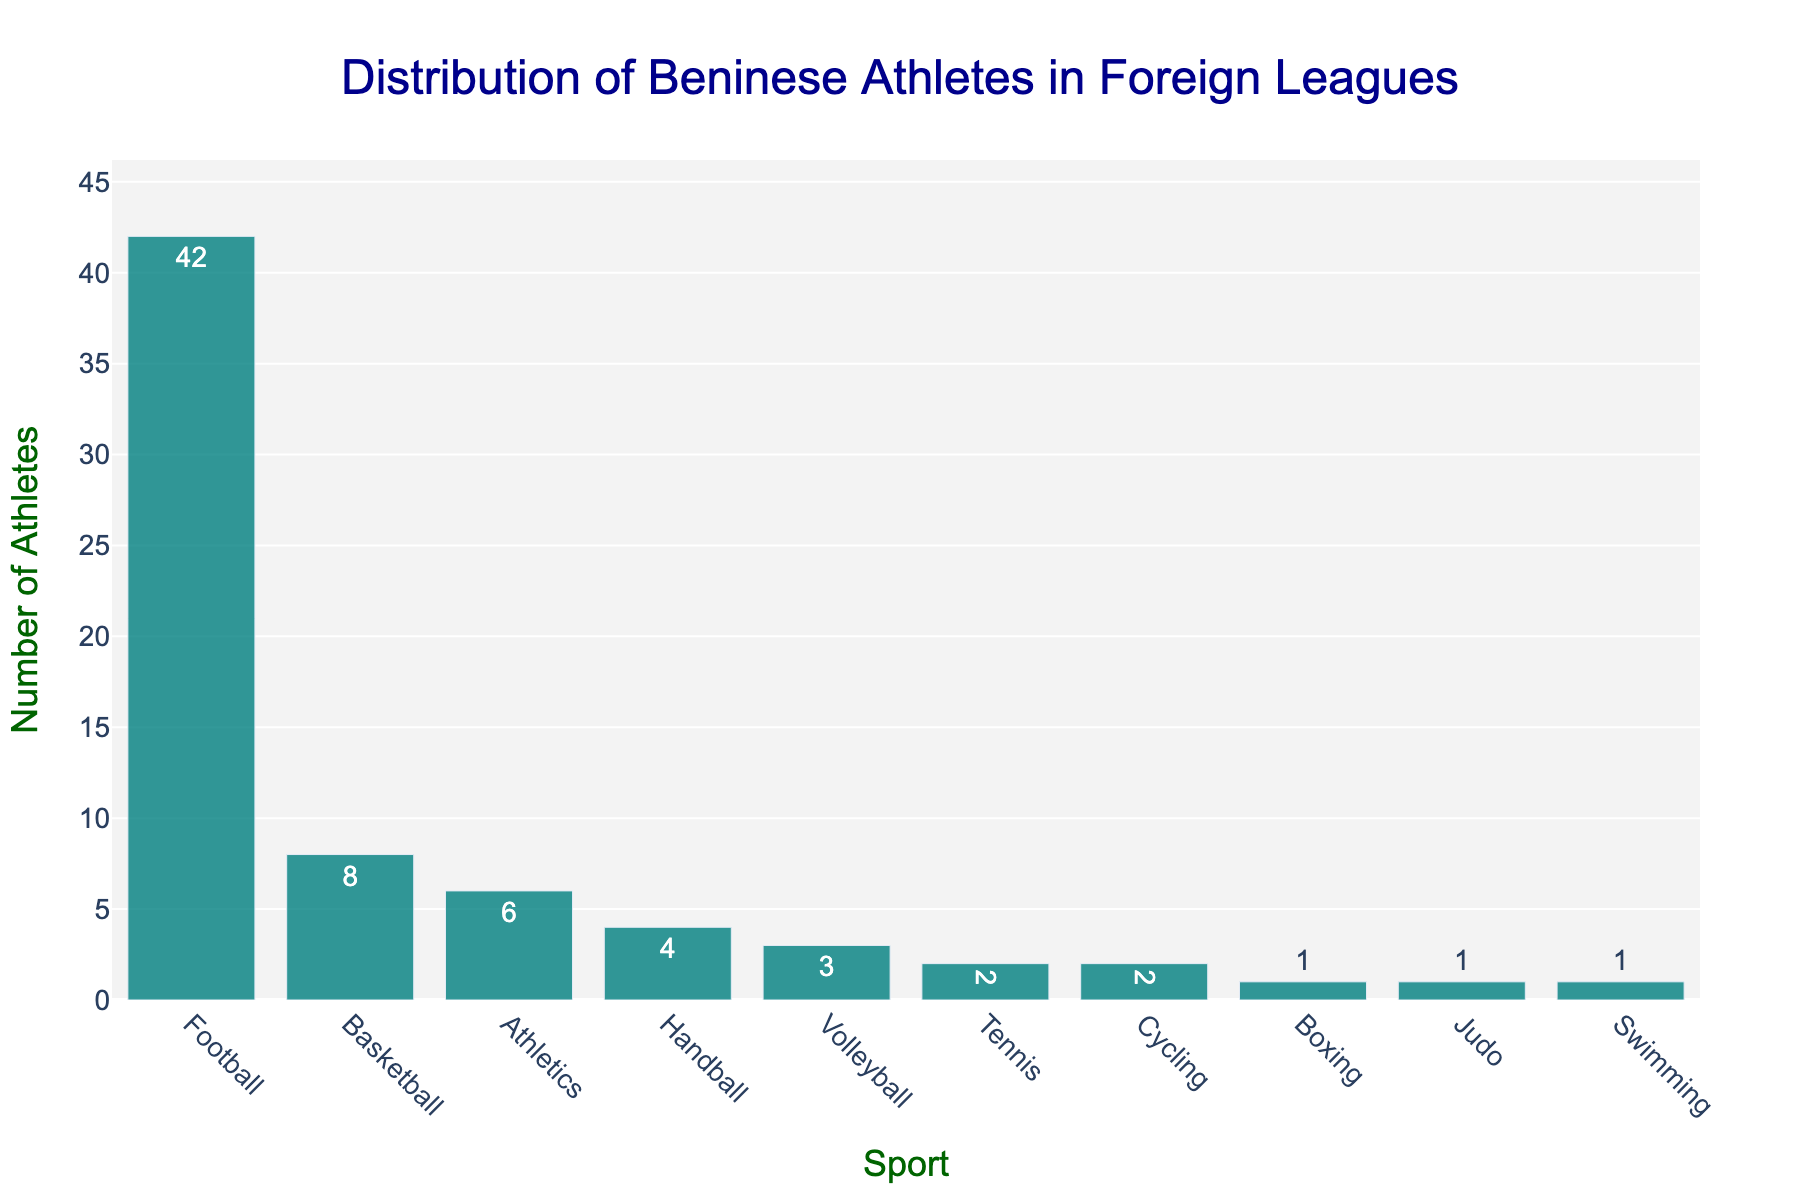What's the most popular sport for Beninese athletes in foreign leagues? The bar representing Football is the tallest in the chart, indicating it has the highest number of athletes.
Answer: Football How many more Beninese athletes play Football compared to Handball in foreign leagues? Football has 42 athletes and Handball has 4 athletes. The difference is 42 - 4.
Answer: 38 Which sport has the least number of Beninese athletes playing in foreign leagues? The bars for Boxing, Judo, and Swimming are the shortest, indicating these sports have the lowest number of athletes, which is 1 each.
Answer: Boxing, Judo, and Swimming What's the total number of Beninese athletes playing in Athletics and Volleyball combined in foreign leagues? Athletics has 6 athletes and Volleyball has 3 athletes. The total is 6 + 3.
Answer: 9 Are there more Beninese athletes playing Basketball or Athletics in foreign leagues? The bar for Basketball is taller than the bar for Athletics, indicating more athletes. Basketball has 8 athletes, and Athletics has 6.
Answer: Basketball What is the difference between the number of Beninese athletes playing Tennis and those playing Swimming in foreign leagues? Tennis has 2 athletes, and Swimming has 1 athlete. The difference is 2 - 1.
Answer: 1 How many sports have exactly 2 Beninese athletes playing in foreign leagues? The bars for Tennis and Cycling each indicate 2 athletes, making it two sports.
Answer: 2 Is the number of athletes playing Handball greater than the number of athletes playing Volleyball? The bar for Handball is slightly taller, showing 4 athletes, while Volleyball has 3.
Answer: Yes What is the average number of Beninese athletes playing in foreign leagues for sports with more than 3 athletes? Sports with more than 3 athletes are Football (42), Basketball (8), and Athletics (6). The total number is 42 + 8 + 6 = 56, over 3 sports. The average is 56 / 3.
Answer: 18.67 How many total Beninese athletes are playing in foreign leagues across all sports? Add all athletes: 42 (Football) + 8 (Basketball) + 6 (Athletics) + 4 (Handball) + 3 (Volleyball) + 2 (Tennis) + 2 (Cycling) + 1 (Boxing) + 1 (Judo) + 1 (Swimming) = 70.
Answer: 70 